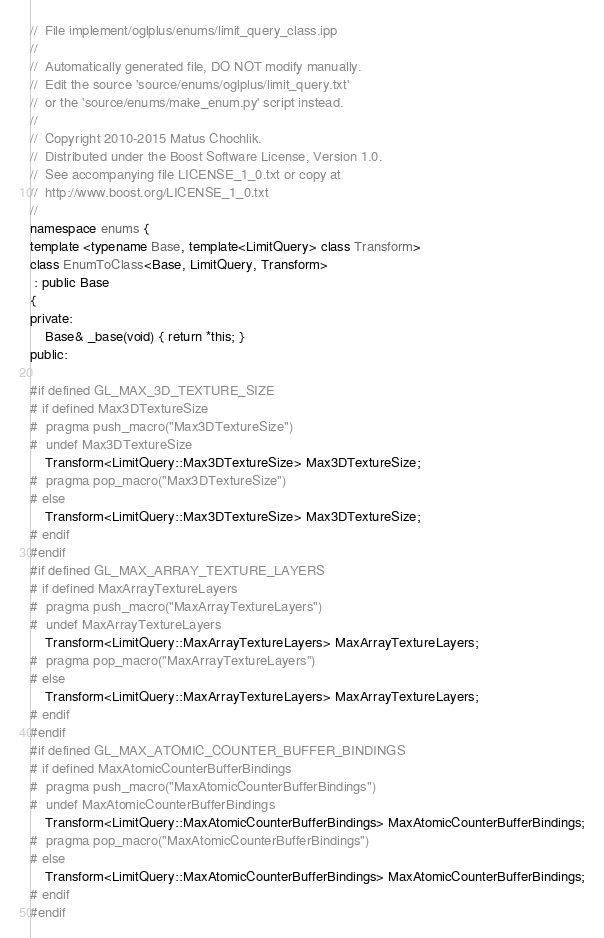<code> <loc_0><loc_0><loc_500><loc_500><_C++_>//  File implement/oglplus/enums/limit_query_class.ipp
//
//  Automatically generated file, DO NOT modify manually.
//  Edit the source 'source/enums/oglplus/limit_query.txt'
//  or the 'source/enums/make_enum.py' script instead.
//
//  Copyright 2010-2015 Matus Chochlik.
//  Distributed under the Boost Software License, Version 1.0.
//  See accompanying file LICENSE_1_0.txt or copy at
//  http://www.boost.org/LICENSE_1_0.txt
//
namespace enums {
template <typename Base, template<LimitQuery> class Transform>
class EnumToClass<Base, LimitQuery, Transform>
 : public Base
{
private:
	Base& _base(void) { return *this; }
public:

#if defined GL_MAX_3D_TEXTURE_SIZE
# if defined Max3DTextureSize
#  pragma push_macro("Max3DTextureSize")
#  undef Max3DTextureSize
	Transform<LimitQuery::Max3DTextureSize> Max3DTextureSize;
#  pragma pop_macro("Max3DTextureSize")
# else
	Transform<LimitQuery::Max3DTextureSize> Max3DTextureSize;
# endif
#endif
#if defined GL_MAX_ARRAY_TEXTURE_LAYERS
# if defined MaxArrayTextureLayers
#  pragma push_macro("MaxArrayTextureLayers")
#  undef MaxArrayTextureLayers
	Transform<LimitQuery::MaxArrayTextureLayers> MaxArrayTextureLayers;
#  pragma pop_macro("MaxArrayTextureLayers")
# else
	Transform<LimitQuery::MaxArrayTextureLayers> MaxArrayTextureLayers;
# endif
#endif
#if defined GL_MAX_ATOMIC_COUNTER_BUFFER_BINDINGS
# if defined MaxAtomicCounterBufferBindings
#  pragma push_macro("MaxAtomicCounterBufferBindings")
#  undef MaxAtomicCounterBufferBindings
	Transform<LimitQuery::MaxAtomicCounterBufferBindings> MaxAtomicCounterBufferBindings;
#  pragma pop_macro("MaxAtomicCounterBufferBindings")
# else
	Transform<LimitQuery::MaxAtomicCounterBufferBindings> MaxAtomicCounterBufferBindings;
# endif
#endif</code> 